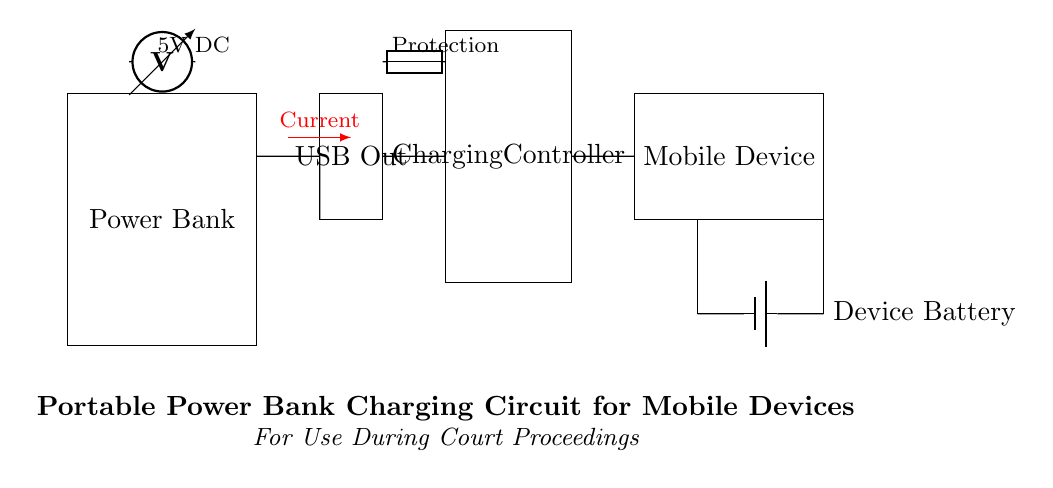What is the voltage indicated in the circuit? The circuit indicates a voltage of 5V, which is noted by the voltmeter symbol positioned at the top center of the diagram.
Answer: 5V What component provides circuit protection? The circuit protection is indicated by the fuse symbol located between the charging controller and the USB output.
Answer: Fuse What is the main function of the charging controller in this circuit? The charging controller regulates the charging process for the mobile device, ensuring safe and efficient power transfer from the power bank.
Answer: Regulates charging How is the current direction depicted in the circuit? The current direction is illustrated by a red arrow with a latex tip pointing from the USB output to the mobile device, indicating the flow of electricity.
Answer: Red arrow What type of battery is represented in the circuit? The battery in the circuit is represented as a battery icon, indicating it is the device battery, which stores energy for the mobile device.
Answer: Device battery How many main components are present in the circuit? The circuit consists of four main components: the power bank, USB output, charging controller, and mobile device.
Answer: Four What does the mobile device connect to in this circuit? The mobile device connects to the charging controller through a short line, allowing it to receive power from the power bank via USB.
Answer: Charging controller 